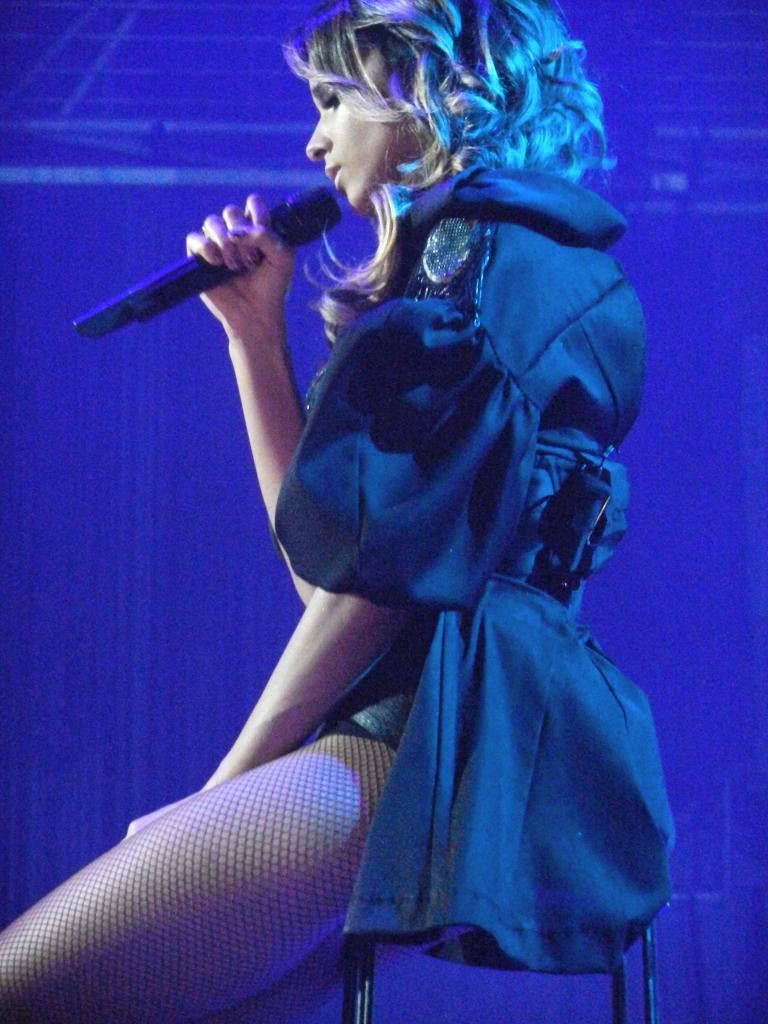Who is the main subject in the image? There is a woman in the image. What is the woman doing in the image? The woman is sitting on a stool. What is the woman wearing in the image? The woman is wearing a black jacket. What object is the woman holding in her hand? The woman is holding a mic in her hand. What type of cloud can be seen in the image? There is no cloud present in the image; it features a woman sitting on a stool and holding a mic. What impulse might have led the woman to hold the mic in the image? The image does not provide information about the woman's motivation or impulse for holding the mic. 